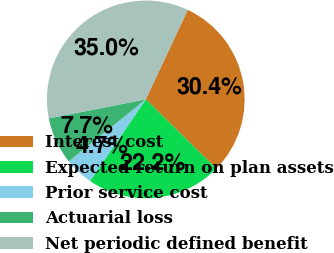Convert chart to OTSL. <chart><loc_0><loc_0><loc_500><loc_500><pie_chart><fcel>Interest cost<fcel>Expected return on plan assets<fcel>Prior service cost<fcel>Actuarial loss<fcel>Net periodic defined benefit<nl><fcel>30.37%<fcel>22.2%<fcel>4.67%<fcel>7.71%<fcel>35.05%<nl></chart> 